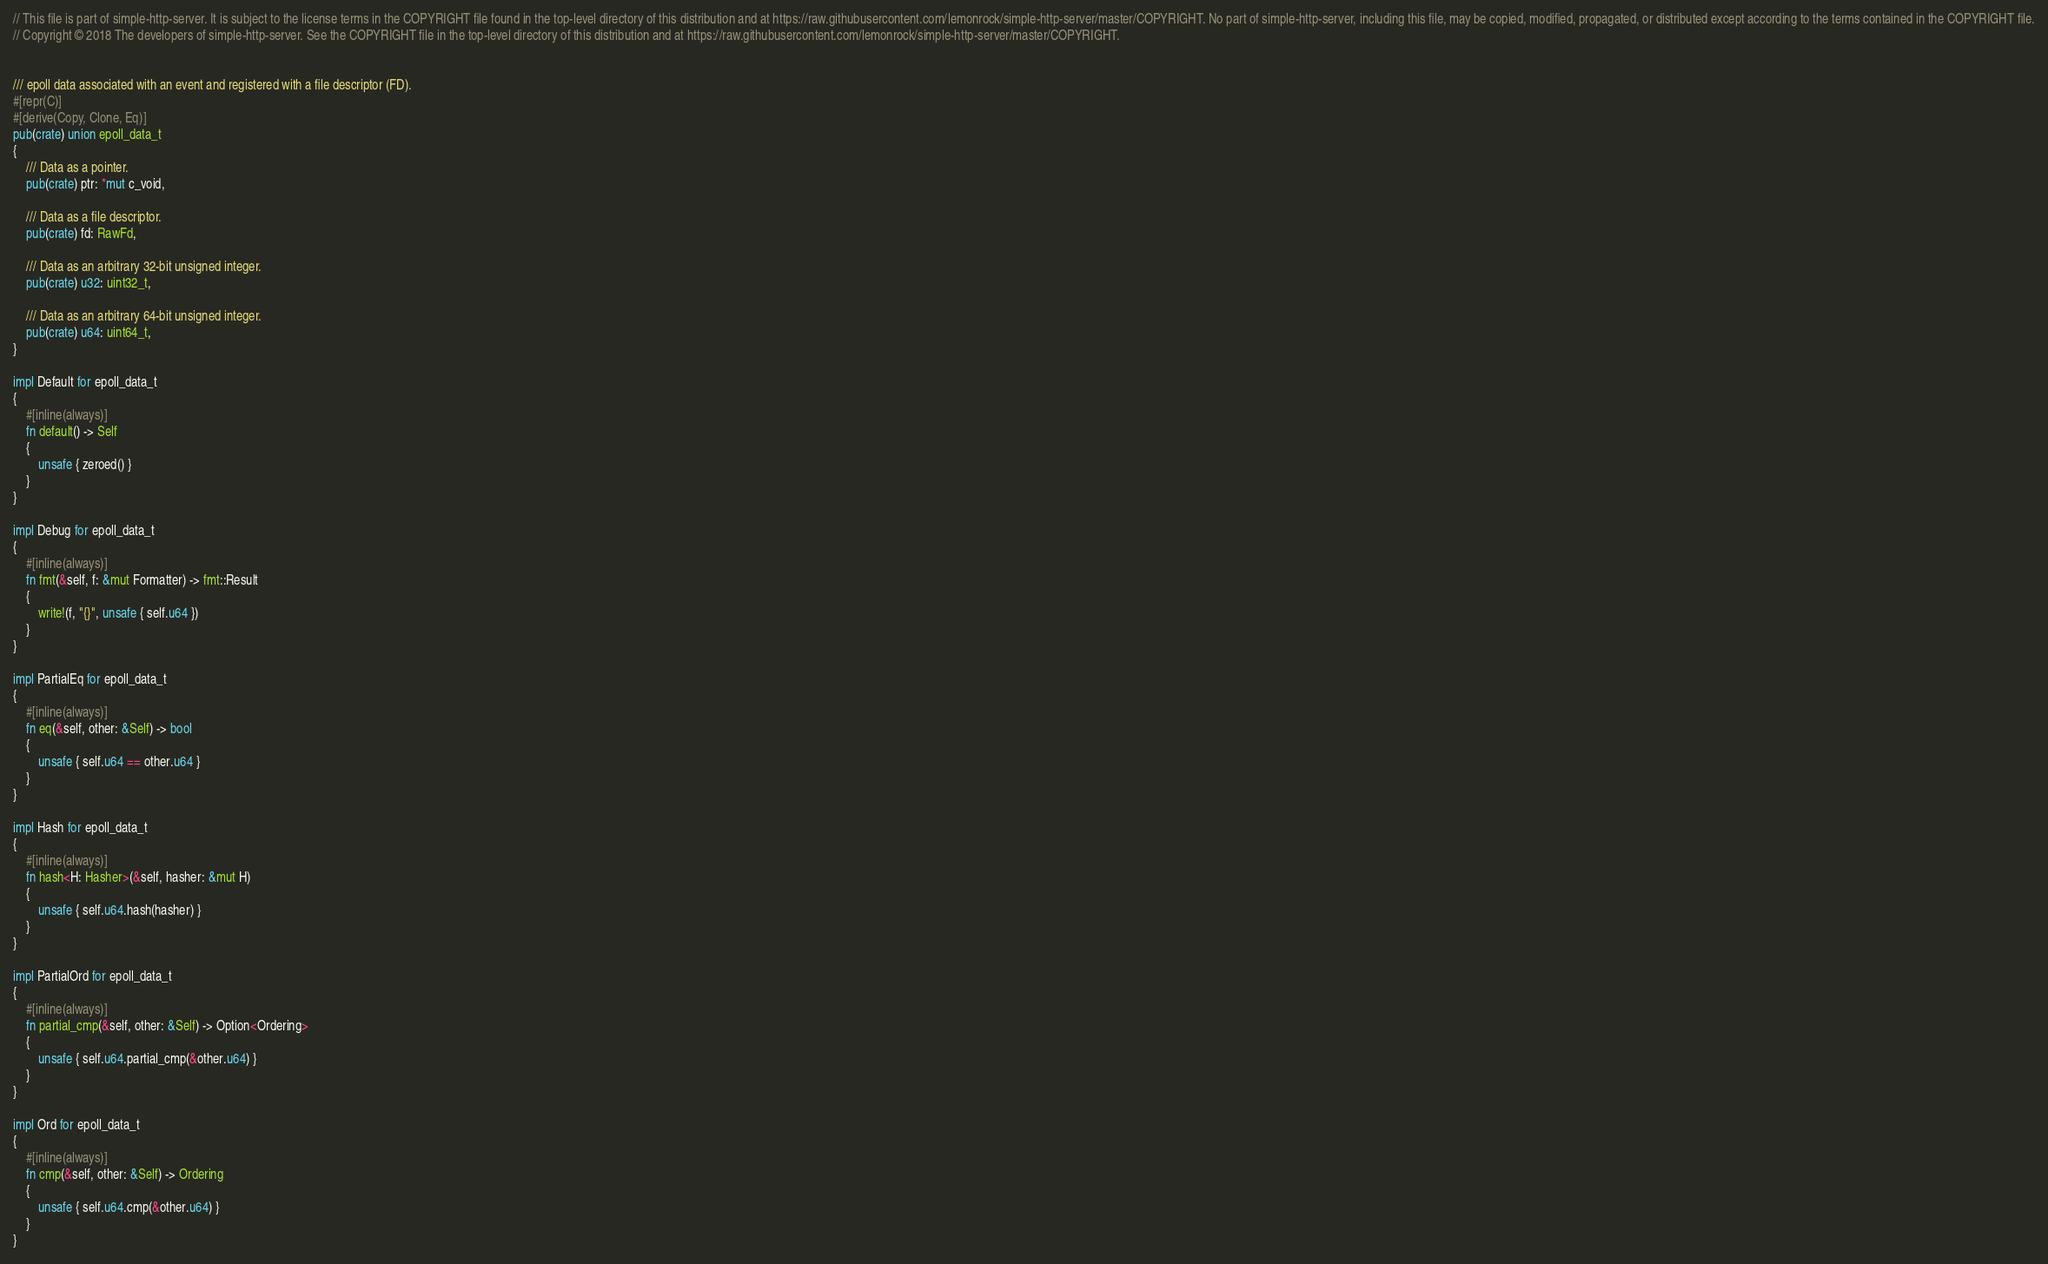Convert code to text. <code><loc_0><loc_0><loc_500><loc_500><_Rust_>// This file is part of simple-http-server. It is subject to the license terms in the COPYRIGHT file found in the top-level directory of this distribution and at https://raw.githubusercontent.com/lemonrock/simple-http-server/master/COPYRIGHT. No part of simple-http-server, including this file, may be copied, modified, propagated, or distributed except according to the terms contained in the COPYRIGHT file.
// Copyright © 2018 The developers of simple-http-server. See the COPYRIGHT file in the top-level directory of this distribution and at https://raw.githubusercontent.com/lemonrock/simple-http-server/master/COPYRIGHT.


/// epoll data associated with an event and registered with a file descriptor (FD).
#[repr(C)]
#[derive(Copy, Clone, Eq)]
pub(crate) union epoll_data_t
{
	/// Data as a pointer.
	pub(crate) ptr: *mut c_void,

	/// Data as a file descriptor.
	pub(crate) fd: RawFd,

	/// Data as an arbitrary 32-bit unsigned integer.
	pub(crate) u32: uint32_t,

	/// Data as an arbitrary 64-bit unsigned integer.
	pub(crate) u64: uint64_t,
}

impl Default for epoll_data_t
{
	#[inline(always)]
	fn default() -> Self
	{
		unsafe { zeroed() }
	}
}

impl Debug for epoll_data_t
{
	#[inline(always)]
	fn fmt(&self, f: &mut Formatter) -> fmt::Result
	{
		write!(f, "{}", unsafe { self.u64 })
	}
}

impl PartialEq for epoll_data_t
{
	#[inline(always)]
	fn eq(&self, other: &Self) -> bool
	{
		unsafe { self.u64 == other.u64 }
	}
}

impl Hash for epoll_data_t
{
	#[inline(always)]
	fn hash<H: Hasher>(&self, hasher: &mut H)
	{
		unsafe { self.u64.hash(hasher) }
	}
}

impl PartialOrd for epoll_data_t
{
	#[inline(always)]
	fn partial_cmp(&self, other: &Self) -> Option<Ordering>
	{
		unsafe { self.u64.partial_cmp(&other.u64) }
	}
}

impl Ord for epoll_data_t
{
	#[inline(always)]
	fn cmp(&self, other: &Self) -> Ordering
	{
		unsafe { self.u64.cmp(&other.u64) }
	}
}
</code> 